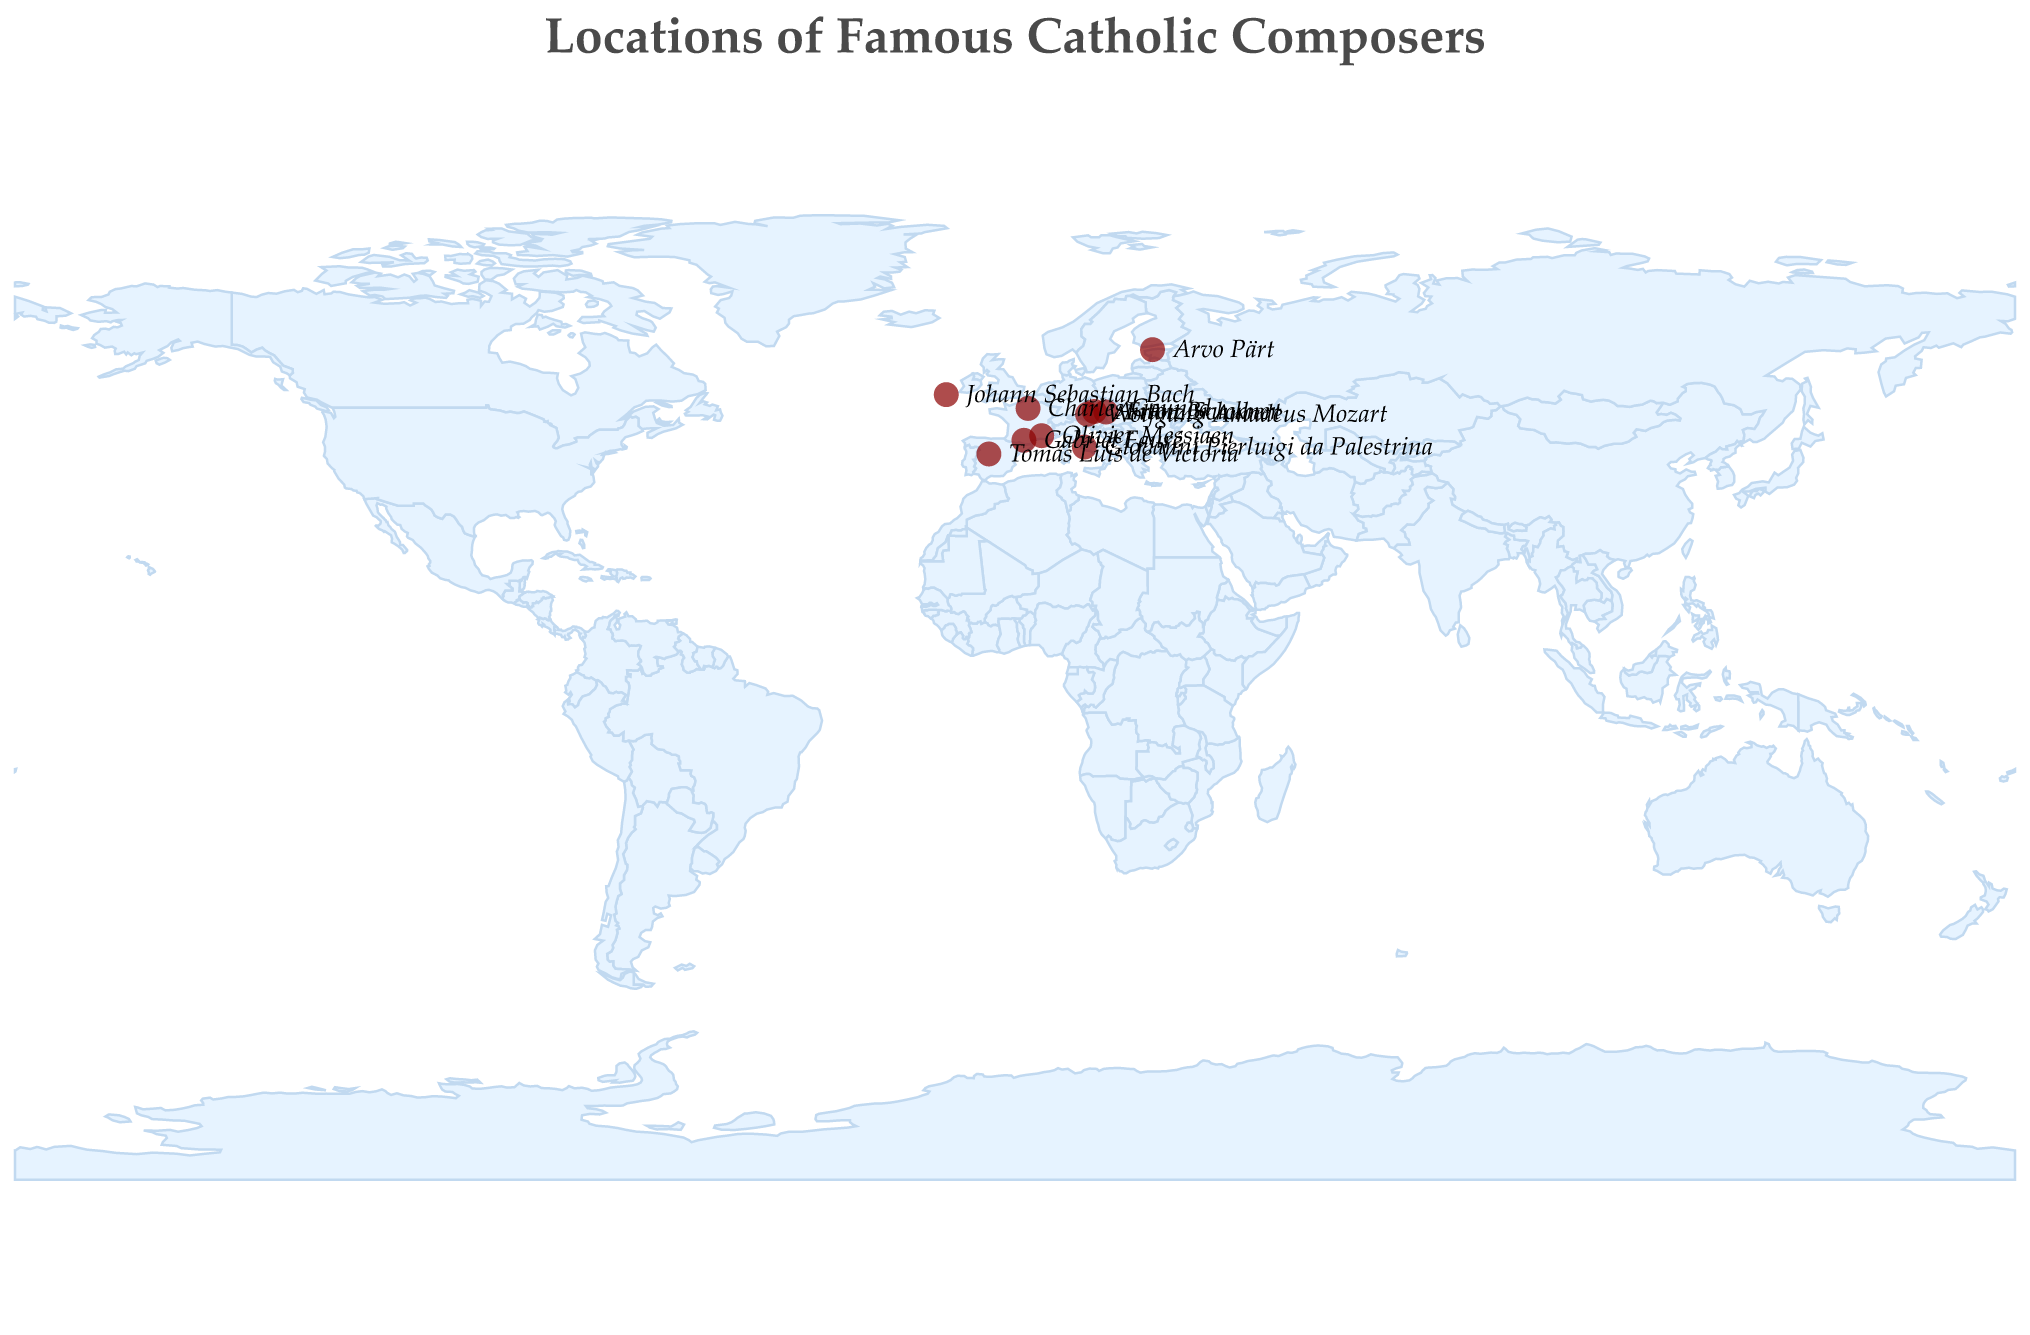What is the title of the figure? The title of the figure is located at the top of the plot. It provides a summary of what the plot is about.
Answer: Locations of Famous Catholic Composers Which country has the most number of composers represented in the plot? To determine the country with the most composers, we review the country mentioned repeatedly in the tooltip information for each data point (the circles) on the map.
Answer: France What is the most performed work of Johann Sebastian Bach? By checking the tooltip information for the data point located in Leipzig, Germany, we find Johann Sebastian Bach's most performed work.
Answer: Mass in B minor Which city is associated with the composer Gabriel Fauré? To identify the city associated with Gabriel Fauré, we locate the tooltip information for him on the plot.
Answer: Pamiers How many composers have their most performed work titled "Ave Maria"? We count the number of data points with the tooltip indicating "Ave Maria" as the most performed work.
Answer: Three Compare the latitude of Vienna and Tallinn. Which is further north? We compare the latitude values of Vienna (48.2082) and Tallinn (59.4370) directly from the data points on the plot. The higher latitude indicates a location further north.
Answer: Tallinn What is the longitude of the location associated with Wolfgang Amadeus Mozart? By checking the tooltip for the data point in Salzburg, Austria, we find the longitude value.
Answer: 13.0550 Identify the composer associated with the city of Linz, Austria. To find the composer, we locate the data point over Linz, Austria, and check the tooltip information.
Answer: Anton Bruckner What is the average latitude of the locations associated with composers from Austria? We calculate the average latitude by adding the latitude values for Salzburg (47.8095), Linz (48.3069), and Vienna (48.2082) and then dividing by the number of locations (3).
Answer: (47.8095 + 48.3069 + 48.2082) / 3 = 48.1082 Which composer is associated with the southernmost location? To determine the southernmost location, we find the data point with the lowest latitude value and check the corresponding composer.
Answer: Tomás Luis de Victoria 